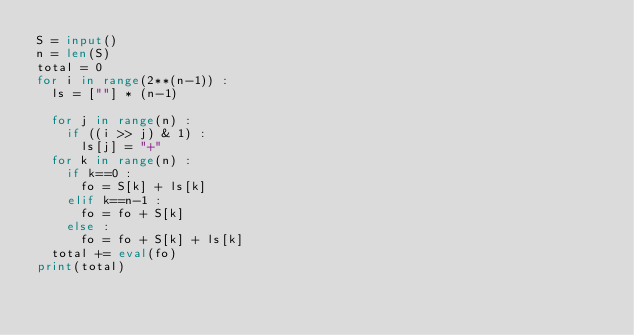<code> <loc_0><loc_0><loc_500><loc_500><_Python_>S = input()
n = len(S)
total = 0
for i in range(2**(n-1)) :
  ls = [""] * (n-1)
  
  for j in range(n) :
    if ((i >> j) & 1) :
      ls[j] = "+"
  for k in range(n) :
    if k==0 :
      fo = S[k] + ls[k]
    elif k==n-1 :
      fo = fo + S[k]
    else :
      fo = fo + S[k] + ls[k]  
  total += eval(fo)
print(total)</code> 